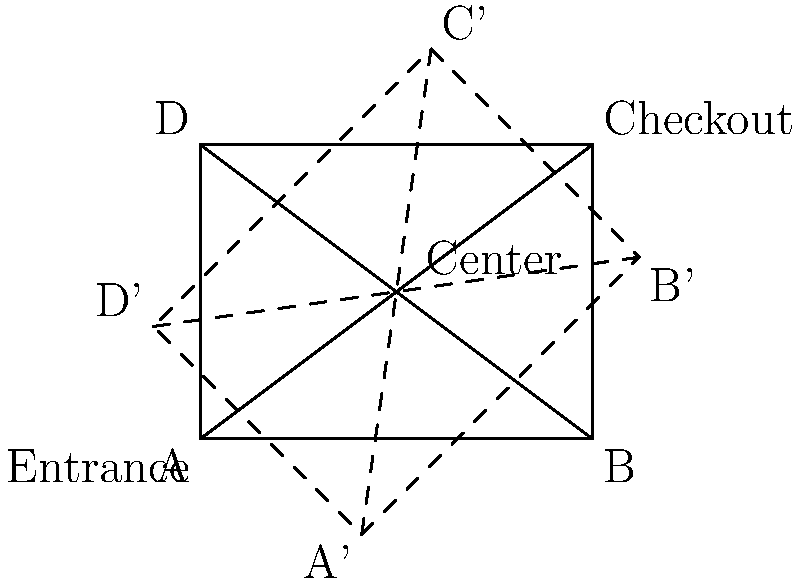A shopping center blueprint is represented by rectangle ABCD, with the entrance at A and checkout at C. To optimize customer flow, you decide to apply a composite transformation. First, you rotate the blueprint 45° clockwise around the center point E, then reflect it across the line connecting the new positions of A and C. What is the resulting transformation of point B? Let's approach this step-by-step:

1) First, we rotate the rectangle 45° clockwise around point E. This moves B to B'.

2) The rotation matrix for a 45° clockwise rotation is:
   $$R = \begin{pmatrix} \cos 45° & \sin 45° \\ -\sin 45° & \cos 45° \end{pmatrix} = \begin{pmatrix} \frac{\sqrt{2}}{2} & \frac{\sqrt{2}}{2} \\ -\frac{\sqrt{2}}{2} & \frac{\sqrt{2}}{2} \end{pmatrix}$$

3) After rotation, we reflect across the line A'C'. This line becomes a new axis of symmetry.

4) Reflection across a line that passes through the origin can be represented by the matrix:
   $$S = \begin{pmatrix} \cos 2\theta & \sin 2\theta \\ \sin 2\theta & -\cos 2\theta \end{pmatrix}$$
   where $\theta$ is the angle between the x-axis and the line of reflection.

5) In this case, A'C' makes a 45° angle with the horizontal, so $\theta = 45°$. Thus, the reflection matrix is:
   $$S = \begin{pmatrix} 0 & 1 \\ 1 & 0 \end{pmatrix}$$

6) The composite transformation is the product of these matrices:
   $$T = S \cdot R = \begin{pmatrix} 0 & 1 \\ 1 & 0 \end{pmatrix} \cdot \begin{pmatrix} \frac{\sqrt{2}}{2} & \frac{\sqrt{2}}{2} \\ -\frac{\sqrt{2}}{2} & \frac{\sqrt{2}}{2} \end{pmatrix} = \begin{pmatrix} -\frac{\sqrt{2}}{2} & \frac{\sqrt{2}}{2} \\ \frac{\sqrt{2}}{2} & \frac{\sqrt{2}}{2} \end{pmatrix}$$

7) This composite transformation matrix represents a rotation by 90° counterclockwise around the origin, followed by a reflection across the y-axis.

Therefore, point B undergoes a 90° rotation counterclockwise around the center point E, followed by a reflection across the vertical line passing through E.
Answer: 90° rotation counterclockwise around E, then reflection across vertical line through E 